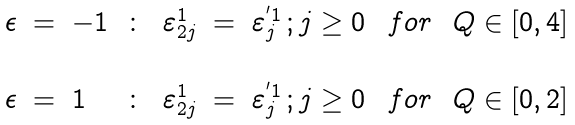<formula> <loc_0><loc_0><loc_500><loc_500>\begin{array} { l l l l l l l l l } \epsilon & = & - 1 & \colon & \varepsilon _ { 2 j } ^ { 1 } & = & \varepsilon _ { j } ^ { ^ { \prime } 1 } \, ; j \geq 0 \, & f o r & \, Q \in [ 0 , 4 ] \\ \\ \epsilon & = & 1 & \colon & \varepsilon _ { 2 j } ^ { 1 } & = & \varepsilon _ { j } ^ { ^ { \prime } 1 } \, ; j \geq 0 \, & f o r & \, Q \in [ 0 , 2 ] \end{array}</formula> 